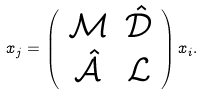<formula> <loc_0><loc_0><loc_500><loc_500>x _ { j } = \left ( \begin{array} { c c } \mathcal { M } & \hat { \mathcal { D } } \\ \hat { \mathcal { A } } & \mathcal { L } \end{array} \right ) x _ { i } .</formula> 